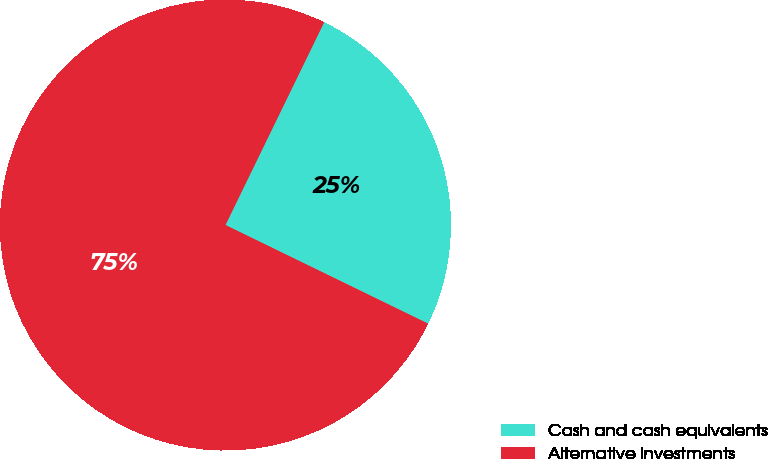Convert chart. <chart><loc_0><loc_0><loc_500><loc_500><pie_chart><fcel>Cash and cash equivalents<fcel>Alternative investments<nl><fcel>25.0%<fcel>75.0%<nl></chart> 